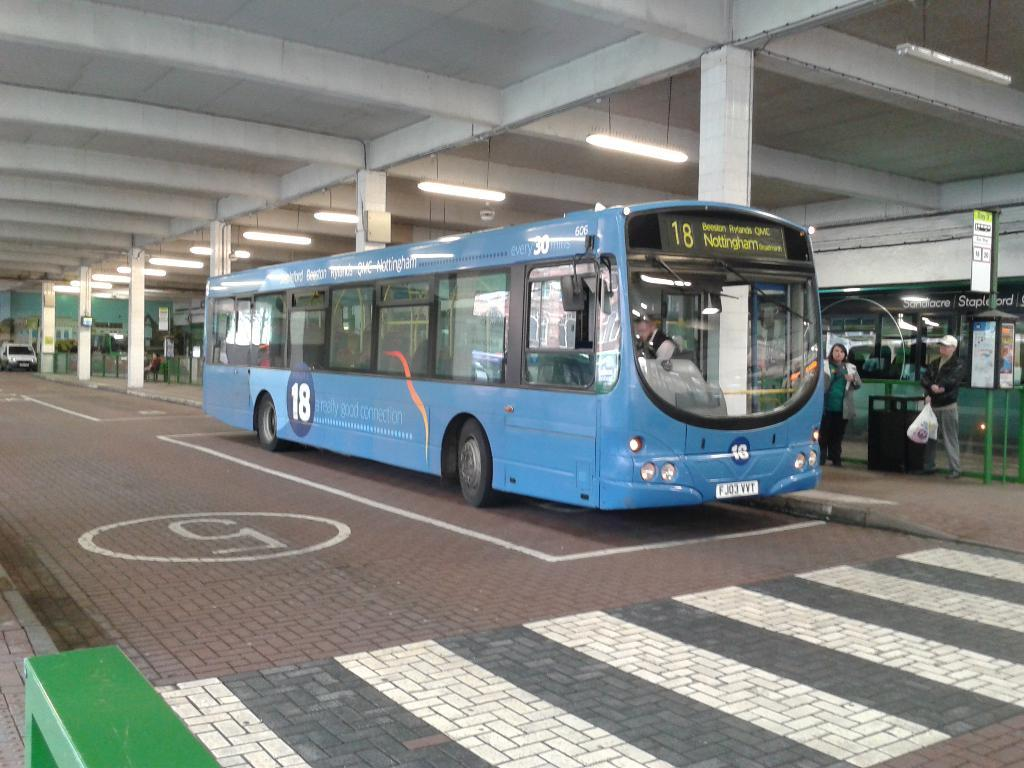Provide a one-sentence caption for the provided image. A blue single decker bus with the number 18 on the front. 